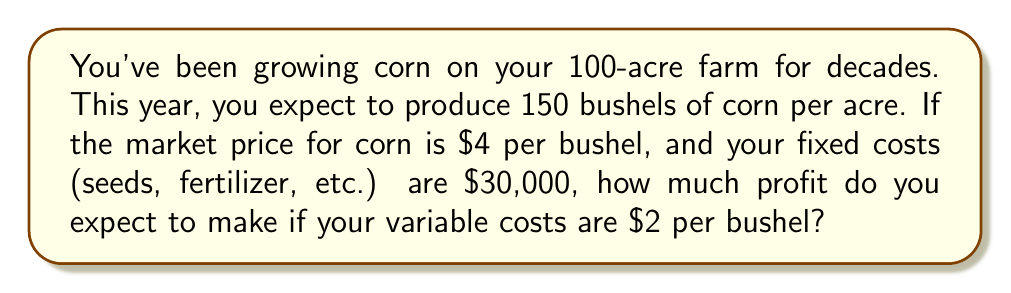What is the answer to this math problem? Let's approach this step-by-step using a linear equation:

1) First, let's define our variables:
   $x$ = number of bushels produced
   $R$ = Revenue
   $C$ = Cost
   $P$ = Profit

2) We can calculate the total number of bushels:
   $x = 100 \text{ acres} \times 150 \text{ bushels/acre} = 15,000 \text{ bushels}$

3) Now, let's set up our revenue equation:
   $R = 4x$ (price per bushel times number of bushels)

4) Our cost equation will be:
   $C = 30,000 + 2x$ (fixed costs plus variable costs per bushel)

5) Profit is revenue minus cost:
   $P = R - C = 4x - (30,000 + 2x) = 4x - 30,000 - 2x = 2x - 30,000$

6) Now we can plug in our total bushels:
   $P = 2(15,000) - 30,000 = 30,000 - 30,000 = 0$

Therefore, in this scenario, you would break even, making $0 profit.
Answer: $0 